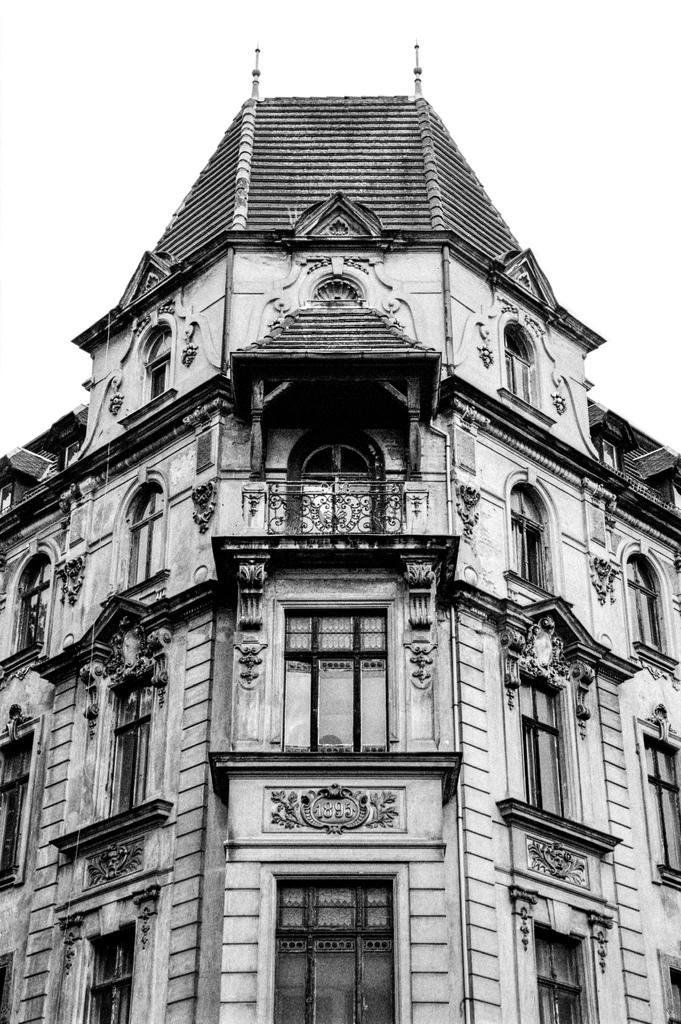Please provide a concise description of this image. This is a black and white image, in the image there is a building. The building has windows and doors. 